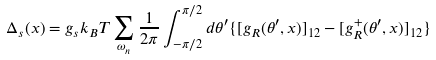<formula> <loc_0><loc_0><loc_500><loc_500>\Delta _ { s } ( x ) = g _ { s } k _ { B } T \sum _ { \omega _ { n } } \frac { 1 } { 2 \pi } \int ^ { \pi / 2 } _ { - \pi / 2 } d \theta ^ { \prime } \{ [ g _ { R } ( \theta ^ { \prime } , x ) ] _ { 1 2 } - [ g ^ { + } _ { R } ( \theta ^ { \prime } , x ) ] _ { 1 2 } \}</formula> 